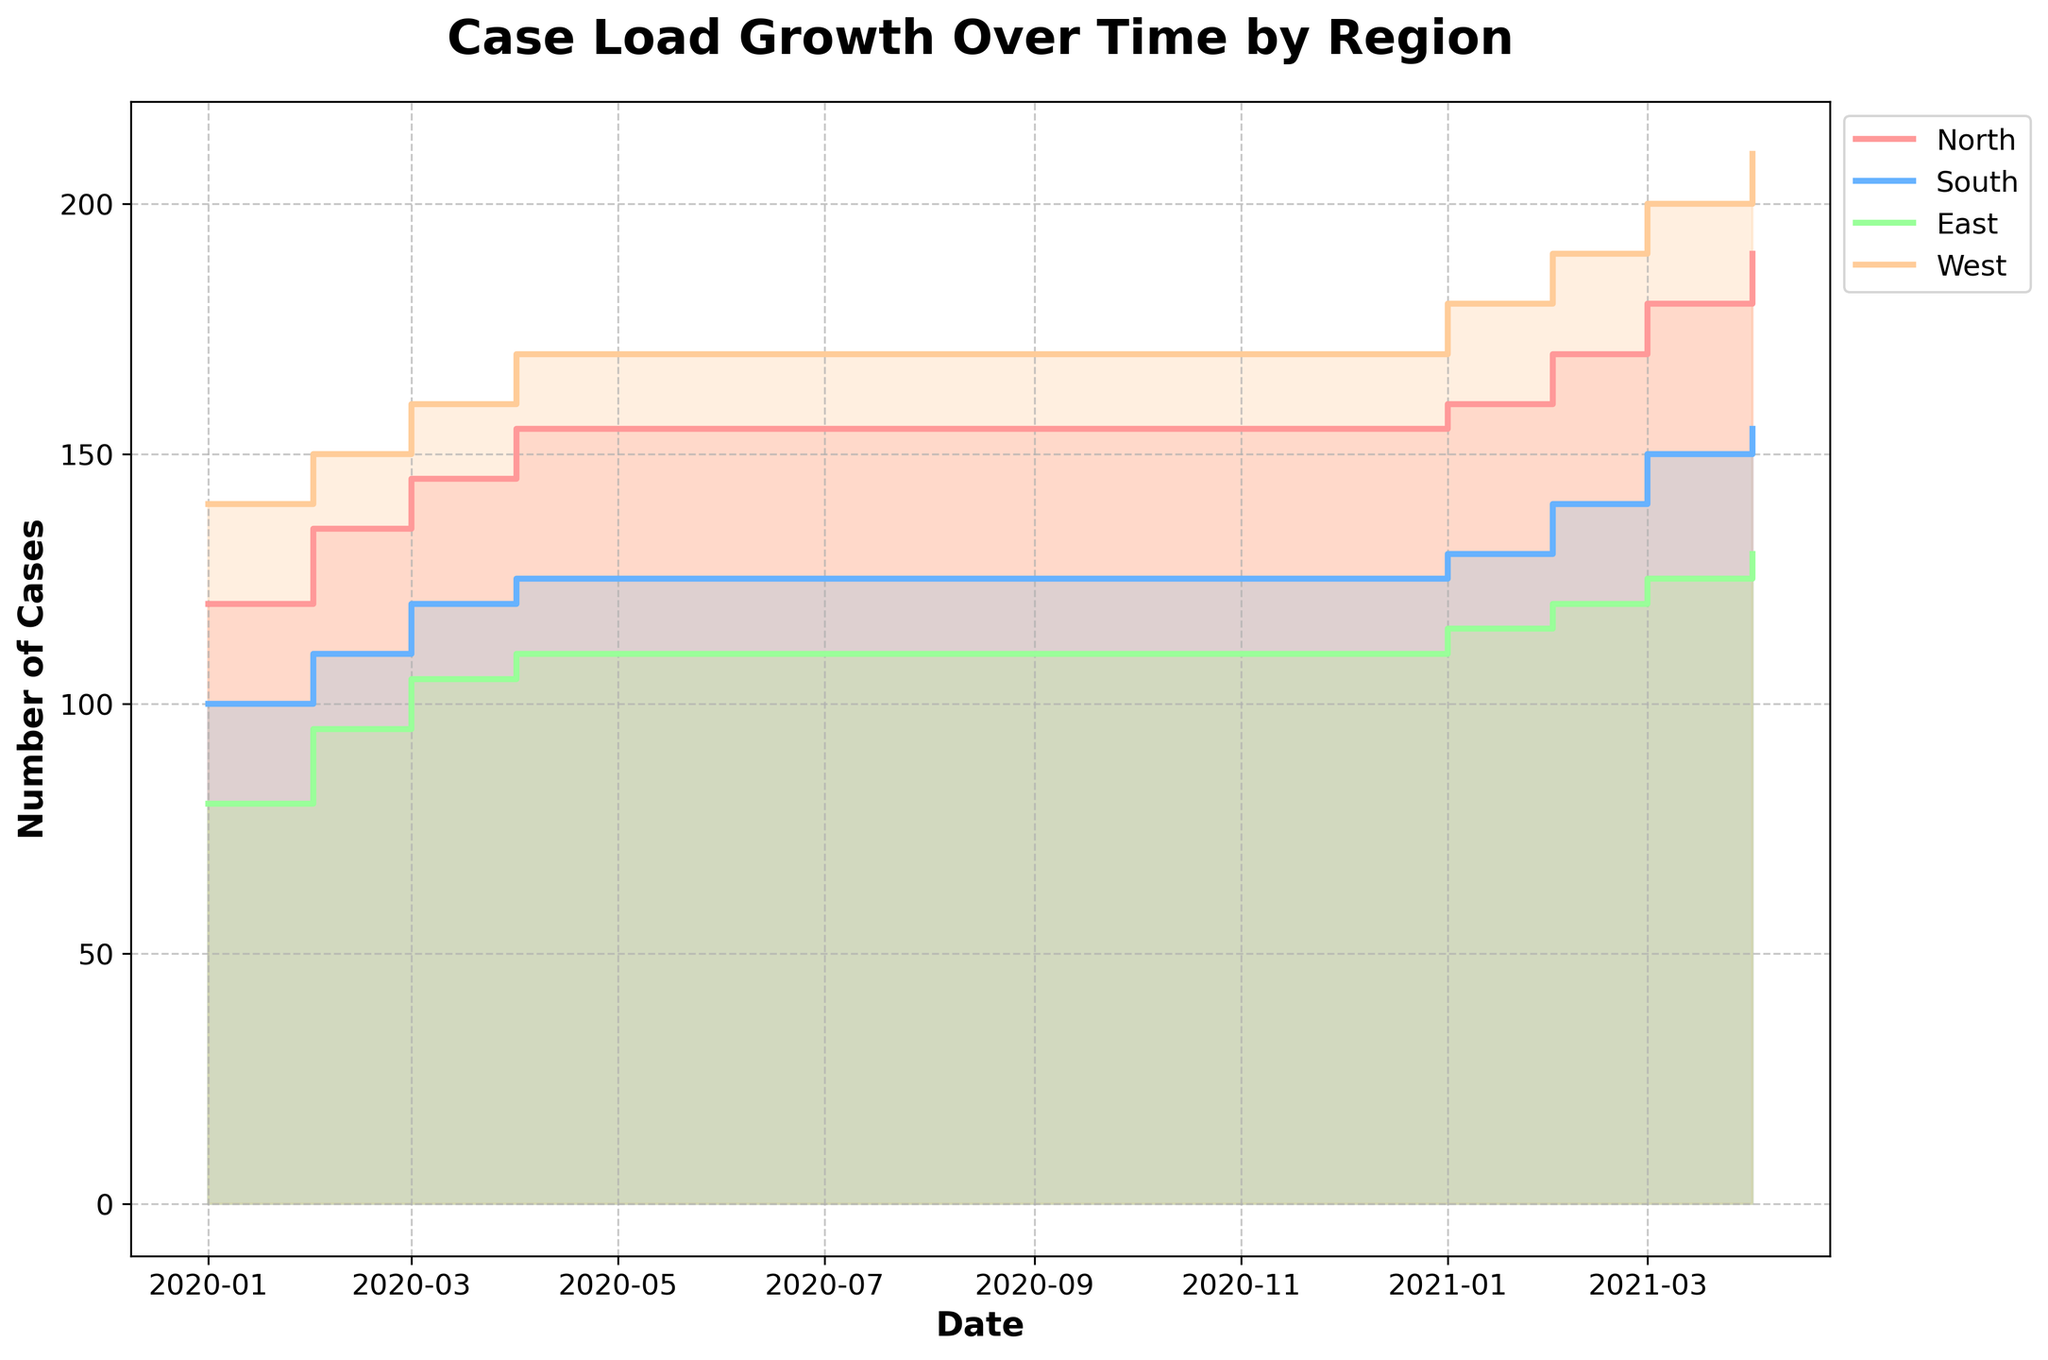What is the title of the figure? The title of the figure is prominently placed at the top of the chart in bold and large font size.
Answer: Case Load Growth Over Time by Region Which region had the highest number of cases at the end of the time period? To determine this, look at the last data point for each region in the chart. The region with the highest step or fill at the far right end of the chart has the highest number of cases.
Answer: West How many regions are represented in the figure? The number of regions can be identified by counting the different colored lines and areas in the legend.
Answer: 4 What was the number of cases in the South region in Q4 2020? To find this, locate the data point on the chart for the South region (identified by its color from the legend) corresponding to Q4 2020.
Answer: 125 Between Q1 2020 and Q4 2021, which region had the most consistent increase in case load? Observe the step heights and the regularity of their increases for each region. The region with the most evenly spaced steps suggests a consistent increase.
Answer: North Which quarter in 2021 did the North region first reach or exceed 170 cases? Track the North region's line to see where it first crosses the 170 case mark in 2021.
Answer: Q2 2021 How much did the number of cases in the North region increase from Q1 2020 to Q4 2021? Subtract the number of cases in Q1 2020 (120) from the number of cases in Q4 2021 (190) for the North region.
Answer: 70 Compare the East and South regions in terms of the number of cases in Q1 2020. Which had more cases, and by how much? Identify the value of cases for both regions in Q1 2020 and then subtract the smaller number from the larger number. The East had 80 cases and the South had 100 cases.
Answer: South had 20 more cases During which period did the West region see a significant jump in cases? Identify where there is a notable large step or steep increase in the West region's trajectory on the chart.
Answer: Q3 2020 to Q4 2020 What general trend can be observed in the case load trend for all regions from 2020 to 2021? By observing all regions' overall step increases, you can see if they generally rise, indicating whether the trend is increasing, decreasing, or remaining stable.
Answer: Increasing 